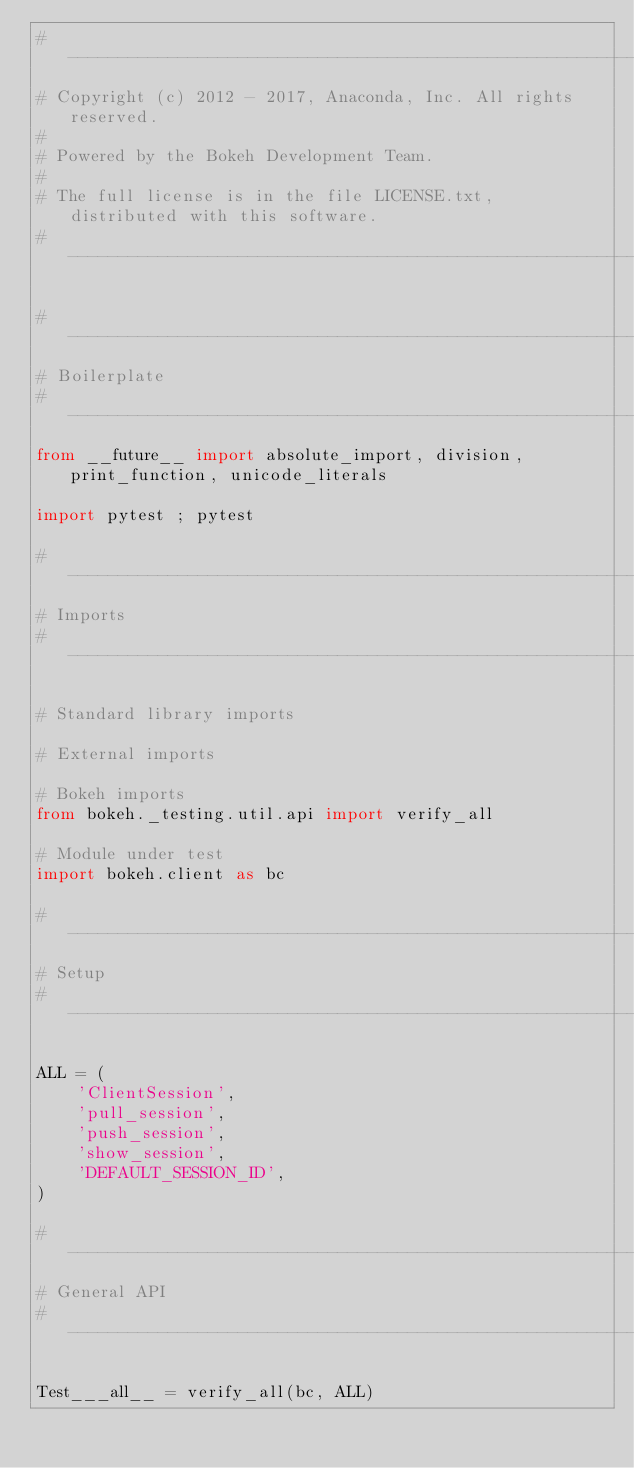<code> <loc_0><loc_0><loc_500><loc_500><_Python_>#-----------------------------------------------------------------------------
# Copyright (c) 2012 - 2017, Anaconda, Inc. All rights reserved.
#
# Powered by the Bokeh Development Team.
#
# The full license is in the file LICENSE.txt, distributed with this software.
#-----------------------------------------------------------------------------

#-----------------------------------------------------------------------------
# Boilerplate
#-----------------------------------------------------------------------------
from __future__ import absolute_import, division, print_function, unicode_literals

import pytest ; pytest

#-----------------------------------------------------------------------------
# Imports
#-----------------------------------------------------------------------------

# Standard library imports

# External imports

# Bokeh imports
from bokeh._testing.util.api import verify_all

# Module under test
import bokeh.client as bc

#-----------------------------------------------------------------------------
# Setup
#-----------------------------------------------------------------------------

ALL = (
    'ClientSession',
    'pull_session',
    'push_session',
    'show_session',
    'DEFAULT_SESSION_ID',
)

#-----------------------------------------------------------------------------
# General API
#-----------------------------------------------------------------------------

Test___all__ = verify_all(bc, ALL)
</code> 